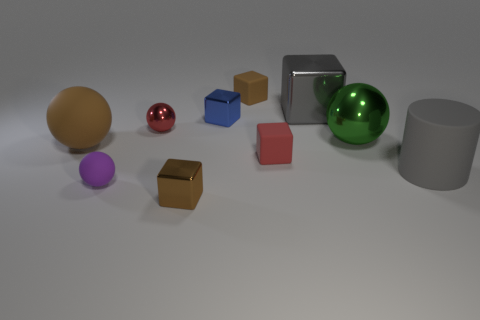Is the rubber cylinder the same color as the big block?
Offer a very short reply. Yes. What is the color of the big cylinder that is made of the same material as the brown sphere?
Your answer should be compact. Gray. How many metal things are either big cylinders or tiny red balls?
Ensure brevity in your answer.  1. Is the cylinder made of the same material as the big green ball?
Make the answer very short. No. What is the shape of the object that is in front of the purple thing?
Give a very brief answer. Cube. There is a big sphere behind the brown matte ball; are there any large objects right of it?
Offer a terse response. Yes. Is there another metallic object that has the same size as the blue thing?
Your answer should be compact. Yes. There is a small rubber block in front of the blue metallic thing; is it the same color as the tiny metal sphere?
Give a very brief answer. Yes. What is the size of the cylinder?
Offer a terse response. Large. There is a gray object in front of the large brown ball to the left of the red rubber thing; what is its size?
Your response must be concise. Large. 